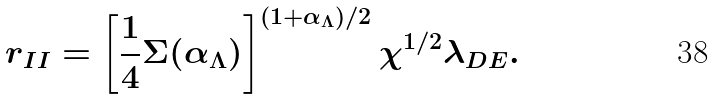Convert formula to latex. <formula><loc_0><loc_0><loc_500><loc_500>r _ { I I } = \left [ \frac { 1 } { 4 } \Sigma ( { \alpha _ { \Lambda } } ) \right ] ^ { ( 1 + { \alpha _ { \Lambda } } ) / 2 } \chi ^ { 1 / 2 } \lambda _ { D E } .</formula> 